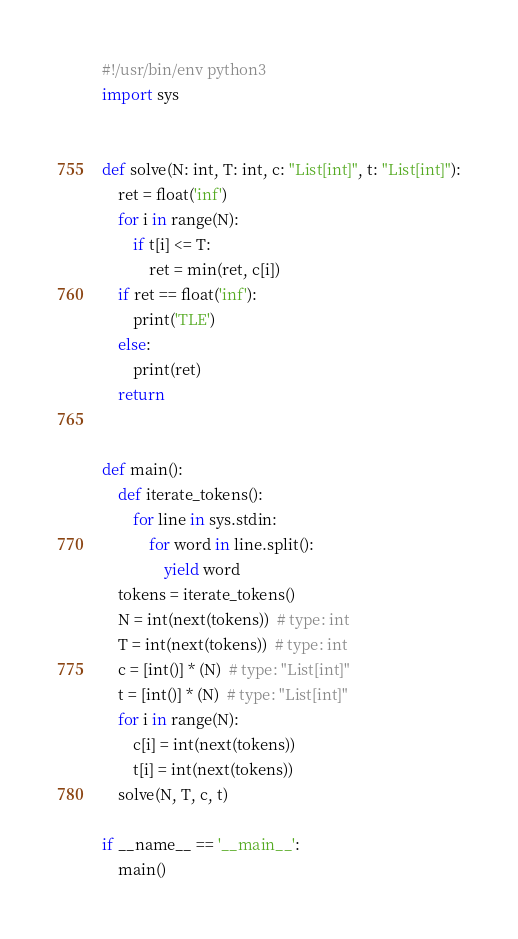Convert code to text. <code><loc_0><loc_0><loc_500><loc_500><_Python_>#!/usr/bin/env python3
import sys


def solve(N: int, T: int, c: "List[int]", t: "List[int]"):
    ret = float('inf')
    for i in range(N):
        if t[i] <= T:
            ret = min(ret, c[i])
    if ret == float('inf'):
        print('TLE')
    else:
        print(ret)
    return


def main():
    def iterate_tokens():
        for line in sys.stdin:
            for word in line.split():
                yield word
    tokens = iterate_tokens()
    N = int(next(tokens))  # type: int
    T = int(next(tokens))  # type: int
    c = [int()] * (N)  # type: "List[int]" 
    t = [int()] * (N)  # type: "List[int]" 
    for i in range(N):
        c[i] = int(next(tokens))
        t[i] = int(next(tokens))
    solve(N, T, c, t)

if __name__ == '__main__':
    main()
</code> 